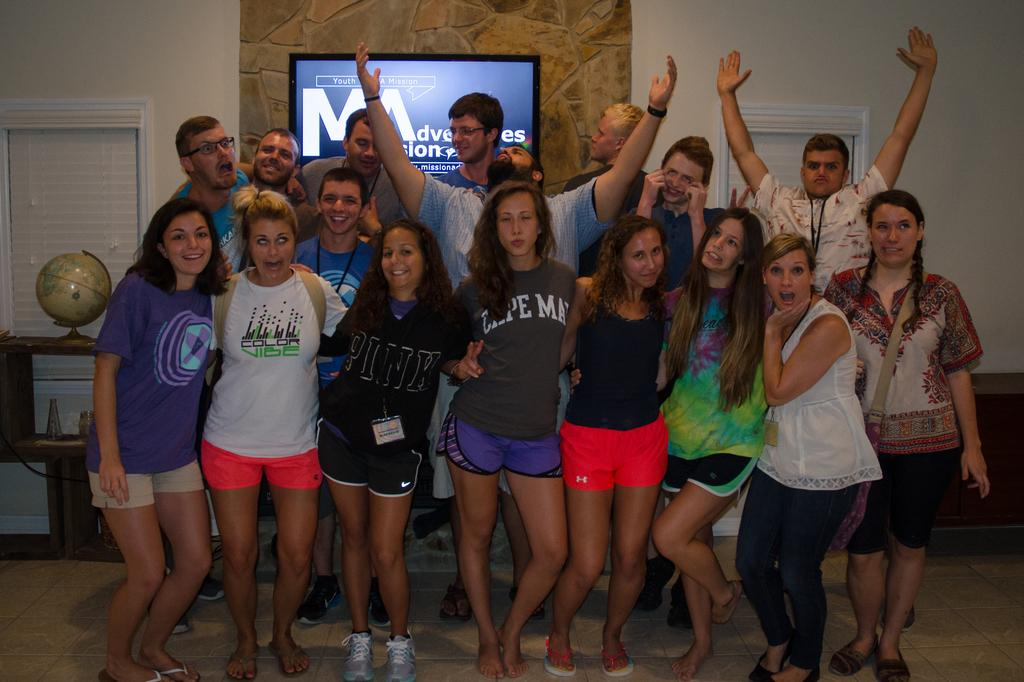What are the people in the image doing? The persons standing on the floor in the image are likely engaged in some activity or conversation. What can be seen on the wall in the background of the image? There is a TV on the wall in the background of the image. What type of natural light source is visible in the background of the image? There are windows in the background of the image. What geographical object is present on a table in the background of the image? There is a globe on a table in the background of the image. What other objects can be seen in the background of the image? There are other objects present in the background of the image, but their specific nature is not mentioned in the provided facts. How many fingers can be seen on the person's hand in the image? The provided facts do not mention any specific details about the persons' hands or fingers, so it is not possible to answer this question definitively. 